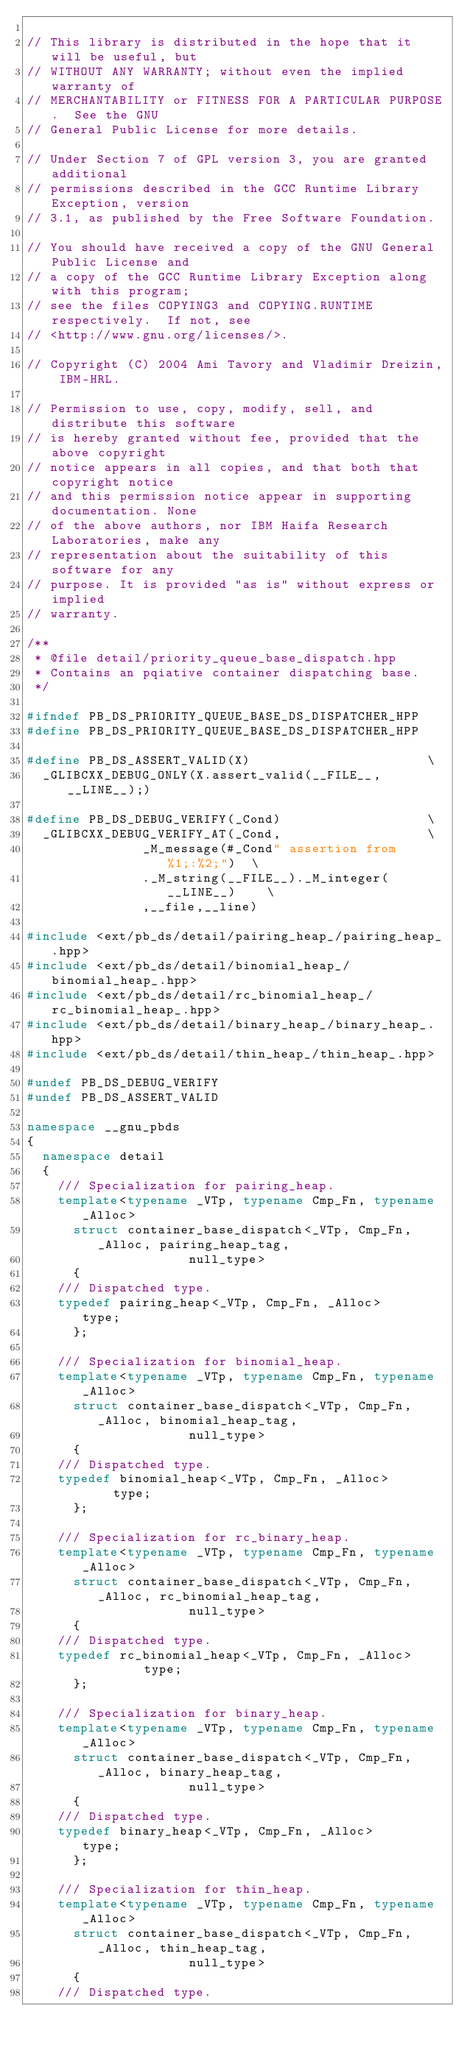<code> <loc_0><loc_0><loc_500><loc_500><_C++_>
// This library is distributed in the hope that it will be useful, but
// WITHOUT ANY WARRANTY; without even the implied warranty of
// MERCHANTABILITY or FITNESS FOR A PARTICULAR PURPOSE.  See the GNU
// General Public License for more details.

// Under Section 7 of GPL version 3, you are granted additional
// permissions described in the GCC Runtime Library Exception, version
// 3.1, as published by the Free Software Foundation.

// You should have received a copy of the GNU General Public License and
// a copy of the GCC Runtime Library Exception along with this program;
// see the files COPYING3 and COPYING.RUNTIME respectively.  If not, see
// <http://www.gnu.org/licenses/>.

// Copyright (C) 2004 Ami Tavory and Vladimir Dreizin, IBM-HRL.

// Permission to use, copy, modify, sell, and distribute this software
// is hereby granted without fee, provided that the above copyright
// notice appears in all copies, and that both that copyright notice
// and this permission notice appear in supporting documentation. None
// of the above authors, nor IBM Haifa Research Laboratories, make any
// representation about the suitability of this software for any
// purpose. It is provided "as is" without express or implied
// warranty.

/**
 * @file detail/priority_queue_base_dispatch.hpp
 * Contains an pqiative container dispatching base.
 */

#ifndef PB_DS_PRIORITY_QUEUE_BASE_DS_DISPATCHER_HPP
#define PB_DS_PRIORITY_QUEUE_BASE_DS_DISPATCHER_HPP

#define PB_DS_ASSERT_VALID(X)						\
  _GLIBCXX_DEBUG_ONLY(X.assert_valid(__FILE__, __LINE__);)

#define PB_DS_DEBUG_VERIFY(_Cond)					\
  _GLIBCXX_DEBUG_VERIFY_AT(_Cond,					\
			   _M_message(#_Cond" assertion from %1;:%2;")	\
			   ._M_string(__FILE__)._M_integer(__LINE__)	\
			   ,__file,__line)

#include <ext/pb_ds/detail/pairing_heap_/pairing_heap_.hpp>
#include <ext/pb_ds/detail/binomial_heap_/binomial_heap_.hpp>
#include <ext/pb_ds/detail/rc_binomial_heap_/rc_binomial_heap_.hpp>
#include <ext/pb_ds/detail/binary_heap_/binary_heap_.hpp>
#include <ext/pb_ds/detail/thin_heap_/thin_heap_.hpp>

#undef PB_DS_DEBUG_VERIFY
#undef PB_DS_ASSERT_VALID

namespace __gnu_pbds
{
  namespace detail
  {
    /// Specialization for pairing_heap.
    template<typename _VTp, typename Cmp_Fn, typename _Alloc>
      struct container_base_dispatch<_VTp, Cmp_Fn, _Alloc, pairing_heap_tag,
				     null_type>
      {
	/// Dispatched type.
	typedef pairing_heap<_VTp, Cmp_Fn, _Alloc> 		type;
      };

    /// Specialization for binomial_heap.
    template<typename _VTp, typename Cmp_Fn, typename _Alloc>
      struct container_base_dispatch<_VTp, Cmp_Fn, _Alloc, binomial_heap_tag,
				     null_type>
      {
	/// Dispatched type.
	typedef binomial_heap<_VTp, Cmp_Fn, _Alloc> 		type;
      };

    /// Specialization for rc_binary_heap.
    template<typename _VTp, typename Cmp_Fn, typename _Alloc>
      struct container_base_dispatch<_VTp, Cmp_Fn, _Alloc, rc_binomial_heap_tag,
  				     null_type>
      {
	/// Dispatched type.
	typedef rc_binomial_heap<_VTp, Cmp_Fn, _Alloc>	       	type;
      };

    /// Specialization for binary_heap.
    template<typename _VTp, typename Cmp_Fn, typename _Alloc>
      struct container_base_dispatch<_VTp, Cmp_Fn, _Alloc, binary_heap_tag,
  				     null_type>
      {
	/// Dispatched type.
	typedef binary_heap<_VTp, Cmp_Fn, _Alloc> 		type;
      };

    /// Specialization for thin_heap.
    template<typename _VTp, typename Cmp_Fn, typename _Alloc>
      struct container_base_dispatch<_VTp, Cmp_Fn, _Alloc, thin_heap_tag,
  				     null_type>    
      {
	/// Dispatched type.</code> 